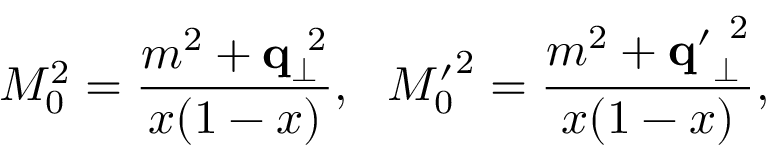<formula> <loc_0><loc_0><loc_500><loc_500>M _ { 0 } ^ { 2 } = \frac { m ^ { 2 } + { q } _ { \bot } ^ { 2 } } { x ( 1 - x ) } , { M _ { 0 } ^ { \prime } } ^ { 2 } = \frac { m ^ { 2 } + { q ^ { \prime } } _ { \bot } ^ { 2 } } { x ( 1 - x ) } ,</formula> 